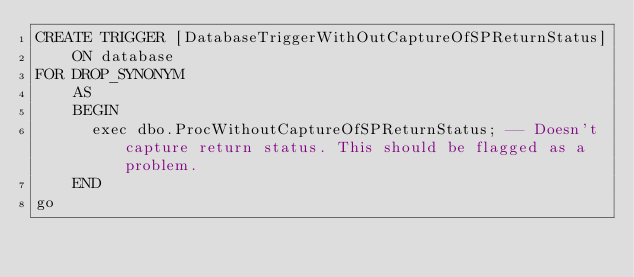Convert code to text. <code><loc_0><loc_0><loc_500><loc_500><_SQL_>CREATE TRIGGER [DatabaseTriggerWithOutCaptureOfSPReturnStatus]
    ON database
FOR DROP_SYNONYM    
    AS
    BEGIN
      exec dbo.ProcWithoutCaptureOfSPReturnStatus; -- Doesn't capture return status. This should be flagged as a problem.
    END
go
</code> 